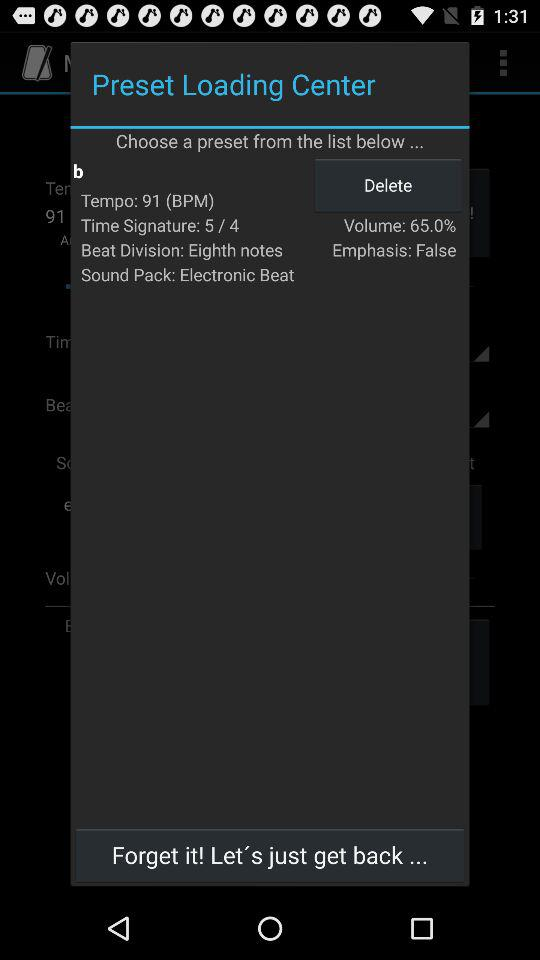What is the status of the emphasis? The status of the emphasis is "False". 